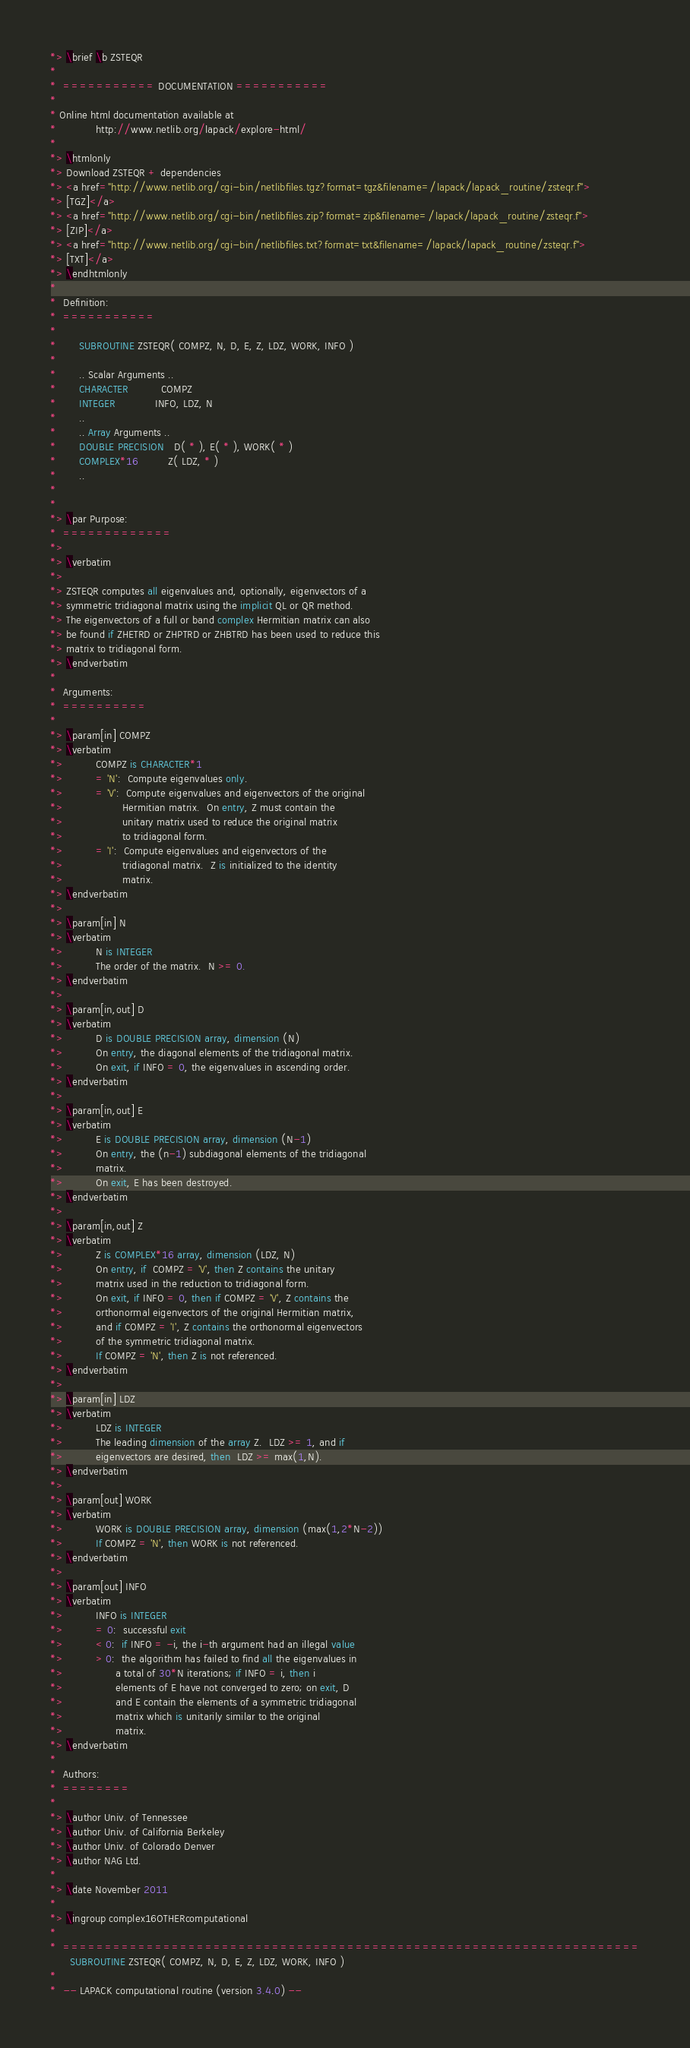Convert code to text. <code><loc_0><loc_0><loc_500><loc_500><_FORTRAN_>*> \brief \b ZSTEQR
*
*  =========== DOCUMENTATION ===========
*
* Online html documentation available at
*            http://www.netlib.org/lapack/explore-html/
*
*> \htmlonly
*> Download ZSTEQR + dependencies
*> <a href="http://www.netlib.org/cgi-bin/netlibfiles.tgz?format=tgz&filename=/lapack/lapack_routine/zsteqr.f">
*> [TGZ]</a>
*> <a href="http://www.netlib.org/cgi-bin/netlibfiles.zip?format=zip&filename=/lapack/lapack_routine/zsteqr.f">
*> [ZIP]</a>
*> <a href="http://www.netlib.org/cgi-bin/netlibfiles.txt?format=txt&filename=/lapack/lapack_routine/zsteqr.f">
*> [TXT]</a>
*> \endhtmlonly
*
*  Definition:
*  ===========
*
*       SUBROUTINE ZSTEQR( COMPZ, N, D, E, Z, LDZ, WORK, INFO )
*
*       .. Scalar Arguments ..
*       CHARACTER          COMPZ
*       INTEGER            INFO, LDZ, N
*       ..
*       .. Array Arguments ..
*       DOUBLE PRECISION   D( * ), E( * ), WORK( * )
*       COMPLEX*16         Z( LDZ, * )
*       ..
*
*
*> \par Purpose:
*  =============
*>
*> \verbatim
*>
*> ZSTEQR computes all eigenvalues and, optionally, eigenvectors of a
*> symmetric tridiagonal matrix using the implicit QL or QR method.
*> The eigenvectors of a full or band complex Hermitian matrix can also
*> be found if ZHETRD or ZHPTRD or ZHBTRD has been used to reduce this
*> matrix to tridiagonal form.
*> \endverbatim
*
*  Arguments:
*  ==========
*
*> \param[in] COMPZ
*> \verbatim
*>          COMPZ is CHARACTER*1
*>          = 'N':  Compute eigenvalues only.
*>          = 'V':  Compute eigenvalues and eigenvectors of the original
*>                  Hermitian matrix.  On entry, Z must contain the
*>                  unitary matrix used to reduce the original matrix
*>                  to tridiagonal form.
*>          = 'I':  Compute eigenvalues and eigenvectors of the
*>                  tridiagonal matrix.  Z is initialized to the identity
*>                  matrix.
*> \endverbatim
*>
*> \param[in] N
*> \verbatim
*>          N is INTEGER
*>          The order of the matrix.  N >= 0.
*> \endverbatim
*>
*> \param[in,out] D
*> \verbatim
*>          D is DOUBLE PRECISION array, dimension (N)
*>          On entry, the diagonal elements of the tridiagonal matrix.
*>          On exit, if INFO = 0, the eigenvalues in ascending order.
*> \endverbatim
*>
*> \param[in,out] E
*> \verbatim
*>          E is DOUBLE PRECISION array, dimension (N-1)
*>          On entry, the (n-1) subdiagonal elements of the tridiagonal
*>          matrix.
*>          On exit, E has been destroyed.
*> \endverbatim
*>
*> \param[in,out] Z
*> \verbatim
*>          Z is COMPLEX*16 array, dimension (LDZ, N)
*>          On entry, if  COMPZ = 'V', then Z contains the unitary
*>          matrix used in the reduction to tridiagonal form.
*>          On exit, if INFO = 0, then if COMPZ = 'V', Z contains the
*>          orthonormal eigenvectors of the original Hermitian matrix,
*>          and if COMPZ = 'I', Z contains the orthonormal eigenvectors
*>          of the symmetric tridiagonal matrix.
*>          If COMPZ = 'N', then Z is not referenced.
*> \endverbatim
*>
*> \param[in] LDZ
*> \verbatim
*>          LDZ is INTEGER
*>          The leading dimension of the array Z.  LDZ >= 1, and if
*>          eigenvectors are desired, then  LDZ >= max(1,N).
*> \endverbatim
*>
*> \param[out] WORK
*> \verbatim
*>          WORK is DOUBLE PRECISION array, dimension (max(1,2*N-2))
*>          If COMPZ = 'N', then WORK is not referenced.
*> \endverbatim
*>
*> \param[out] INFO
*> \verbatim
*>          INFO is INTEGER
*>          = 0:  successful exit
*>          < 0:  if INFO = -i, the i-th argument had an illegal value
*>          > 0:  the algorithm has failed to find all the eigenvalues in
*>                a total of 30*N iterations; if INFO = i, then i
*>                elements of E have not converged to zero; on exit, D
*>                and E contain the elements of a symmetric tridiagonal
*>                matrix which is unitarily similar to the original
*>                matrix.
*> \endverbatim
*
*  Authors:
*  ========
*
*> \author Univ. of Tennessee
*> \author Univ. of California Berkeley
*> \author Univ. of Colorado Denver
*> \author NAG Ltd.
*
*> \date November 2011
*
*> \ingroup complex16OTHERcomputational
*
*  =====================================================================
      SUBROUTINE ZSTEQR( COMPZ, N, D, E, Z, LDZ, WORK, INFO )
*
*  -- LAPACK computational routine (version 3.4.0) --</code> 